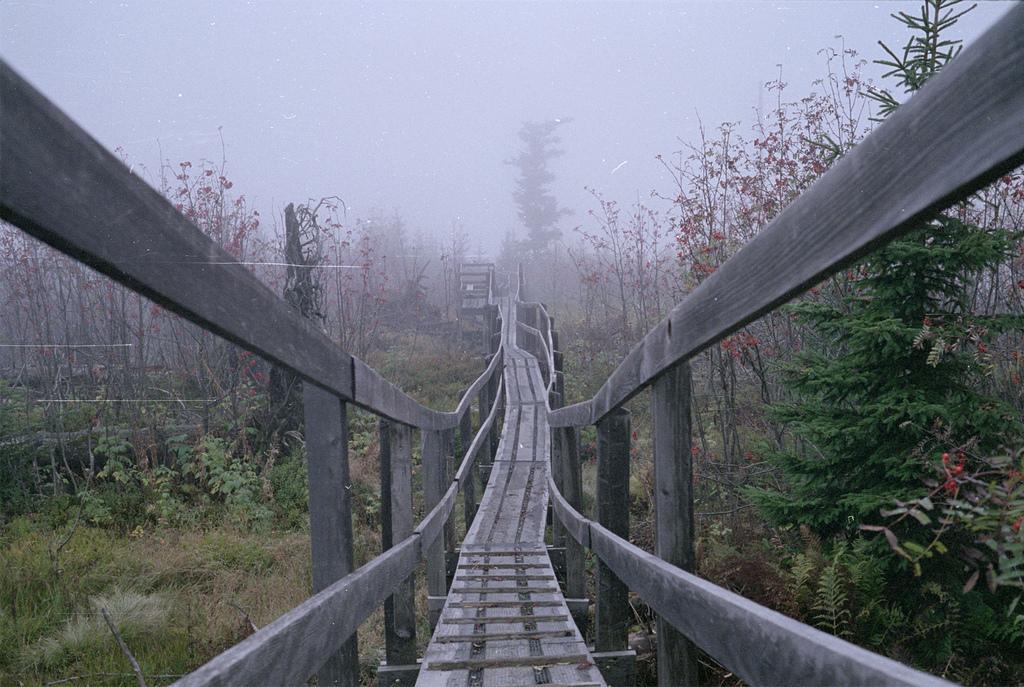In one or two sentences, can you explain what this image depicts? This is completely an outdoor picture. At the top of the picture we can see a sky and it's very blurry. These are the bare trees. This a footover bridge and it is a wooden bridge. There are trees aside to this bridge. 